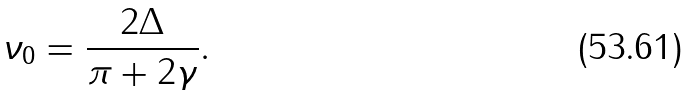Convert formula to latex. <formula><loc_0><loc_0><loc_500><loc_500>\nu _ { 0 } = \frac { 2 \Delta } { \pi + 2 \gamma } .</formula> 